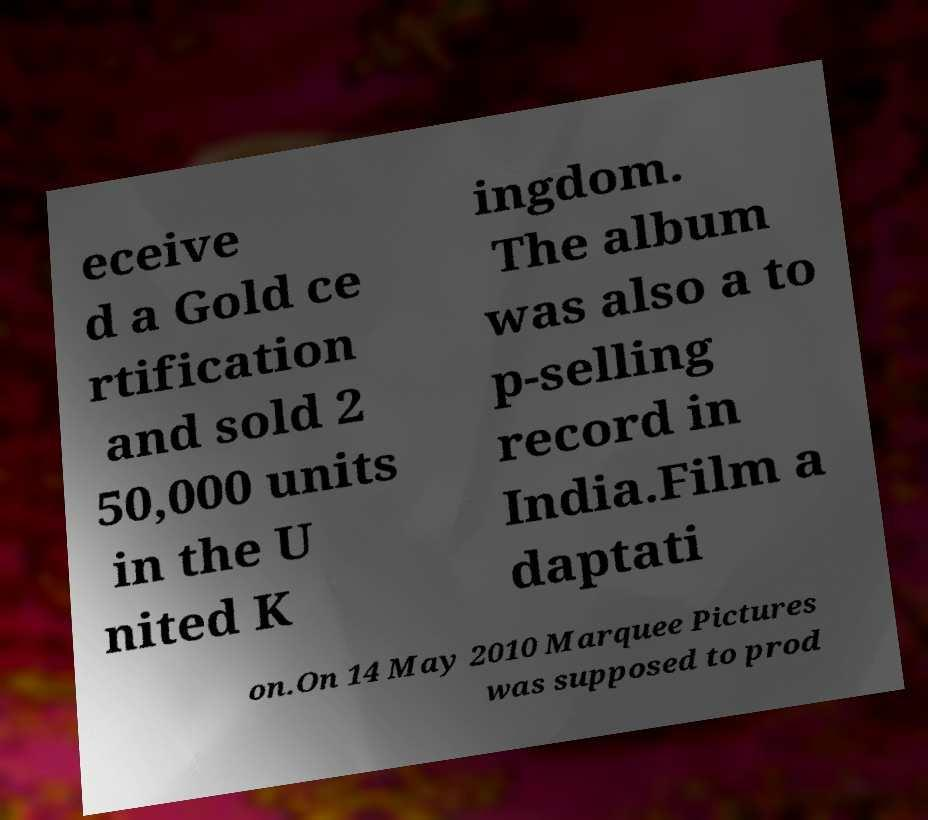There's text embedded in this image that I need extracted. Can you transcribe it verbatim? eceive d a Gold ce rtification and sold 2 50,000 units in the U nited K ingdom. The album was also a to p-selling record in India.Film a daptati on.On 14 May 2010 Marquee Pictures was supposed to prod 